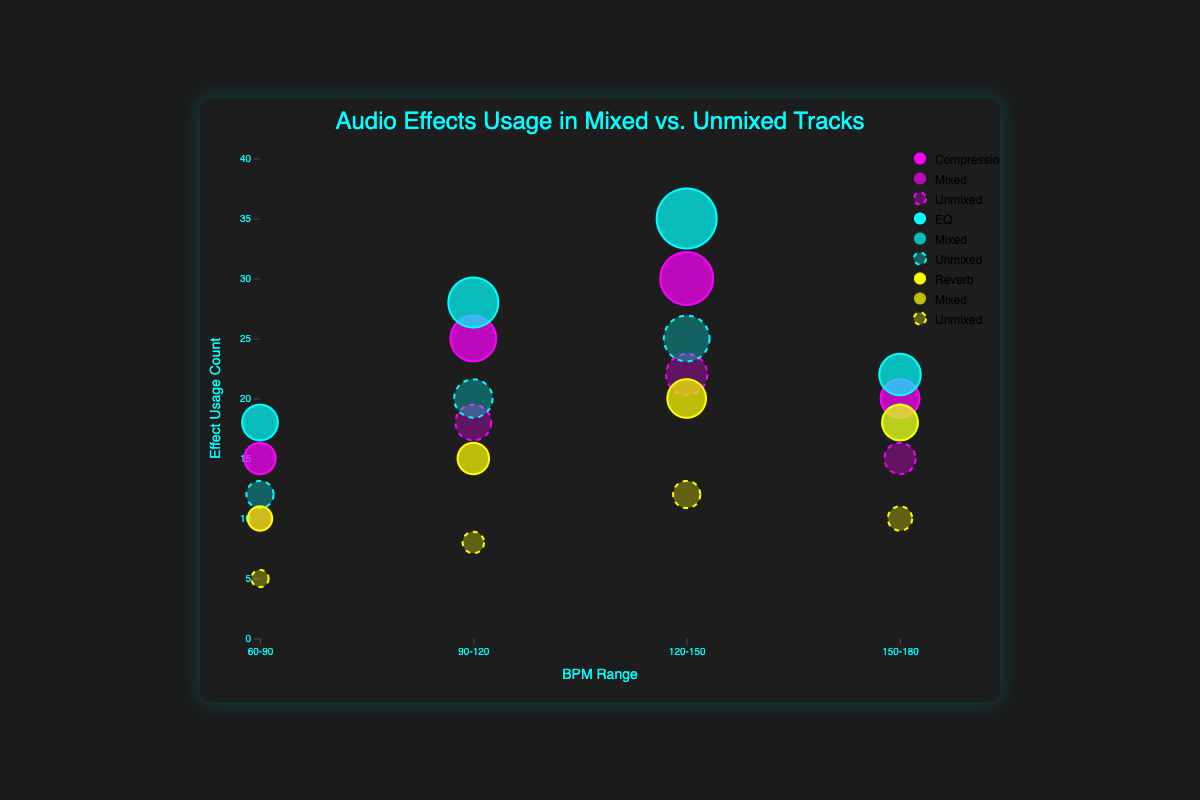How many BPM ranges are shown in the figure? The x-axis shows distinct BPM ranges, which are visually discernible as labeled points. There are 4 labels: "60-90", "90-120", "120-150", and "150-180". Count these labels.
Answer: 4 Which audio effect has the most usage in the mixed tracks at the "120-150" BPM range? The bubbles at the "120-150" BPM range represent different effects and their sizes indicate their usage counts. For mixed tracks, the largest bubble corresponds to the EQ effect with a mixed count of 35.
Answer: EQ What is the difference in usage count for Reverb between mixed and unmixed tracks in the "60-90" BPM range? Compare the mixed and unmixed counts for Reverb at "60-90". Mixed count is 10 and unmixed count is 5. Subtract the unmixed count from the mixed count: 10 - 5 = 5.
Answer: 5 Between EQ and Compression, which effect shows a higher usage count in unmixed tracks at the "90-120" BPM range? Check the sizes of bubbles representing EQ and Compression effects in the "90-120" BPM range for unmixed tracks. EQ's count is 20, whereas Compression's count is 18. Compare these values.
Answer: EQ Which BPM range shows the highest total usage count for mixed tracks when all audio effects are combined? Sum the mixed counts for each BPM range:
60-90: 15 (Compression) + 18 (EQ) + 10 (Reverb) = 43
90-120: 25 (Compression) + 28 (EQ) + 15 (Reverb) = 68
120-150: 30 (Compression) + 35 (EQ) + 20 (Reverb) = 85
150-180: 20 (Compression) + 22 (EQ) + 18 (Reverb) = 60
120-150 has the highest total of 85.
Answer: 120-150 For the "120-150" BPM range, which category (mixed or unmixed) has a larger bubble for the EQ effect? Compare the bubble sizes for EQ in "120-150" for mixed and unmixed categories. Mixed count (bubble size) is 35, and unmixed count is 25. Mixed has a larger bubble.
Answer: Mixed What is the average usage count for Compression in unmixed tracks across all BPM ranges? Add the unmixed counts for Compression across all BPM ranges and divide by the number of ranges:
(10 + 18 + 22 + 15) / 4 = 65 / 4 = 16.25
Answer: 16.25 Comparing the highest usage count for EQ in mixed tracks and Reverb in unmixed tracks, which one is greater and by how much? Identify the highest count for EQ in mixed tracks (35 at "120-150") and for Reverb in unmixed tracks (12 at "120-150"). Subtract the smaller value from the larger: 35 - 12 = 23.
Answer: EQ, by 23 